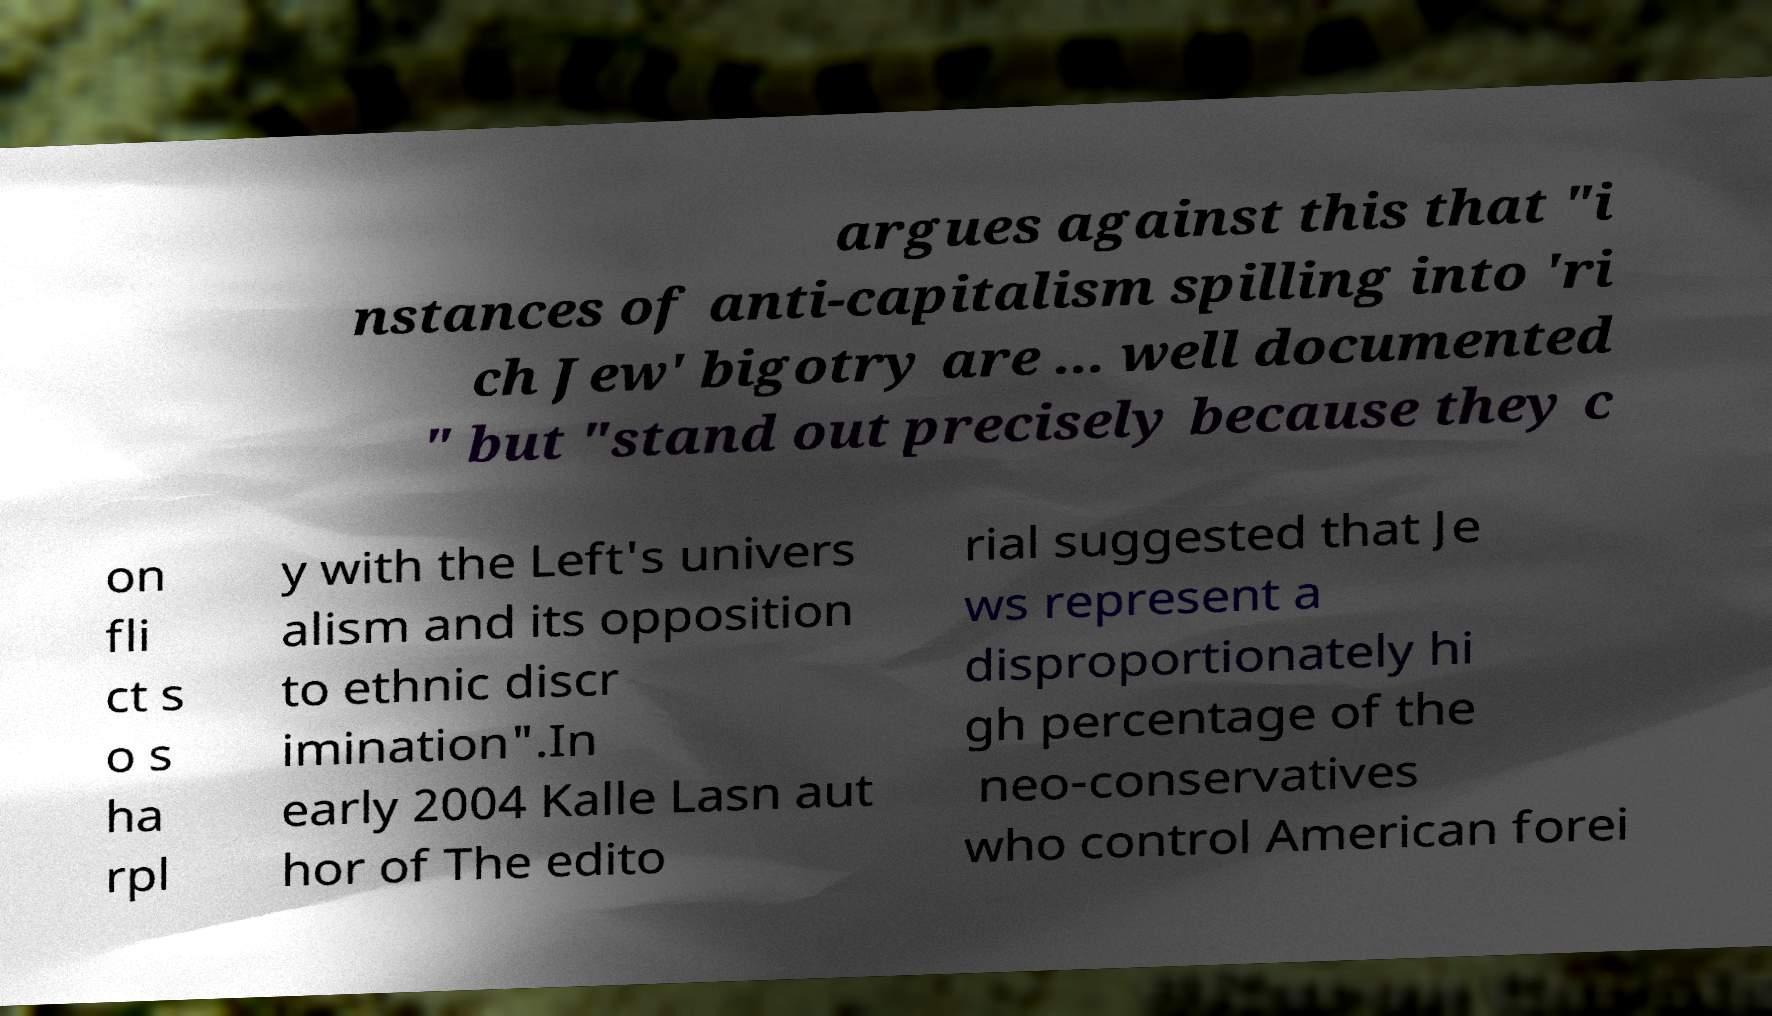Could you extract and type out the text from this image? argues against this that "i nstances of anti-capitalism spilling into 'ri ch Jew' bigotry are ... well documented " but "stand out precisely because they c on fli ct s o s ha rpl y with the Left's univers alism and its opposition to ethnic discr imination".In early 2004 Kalle Lasn aut hor of The edito rial suggested that Je ws represent a disproportionately hi gh percentage of the neo-conservatives who control American forei 